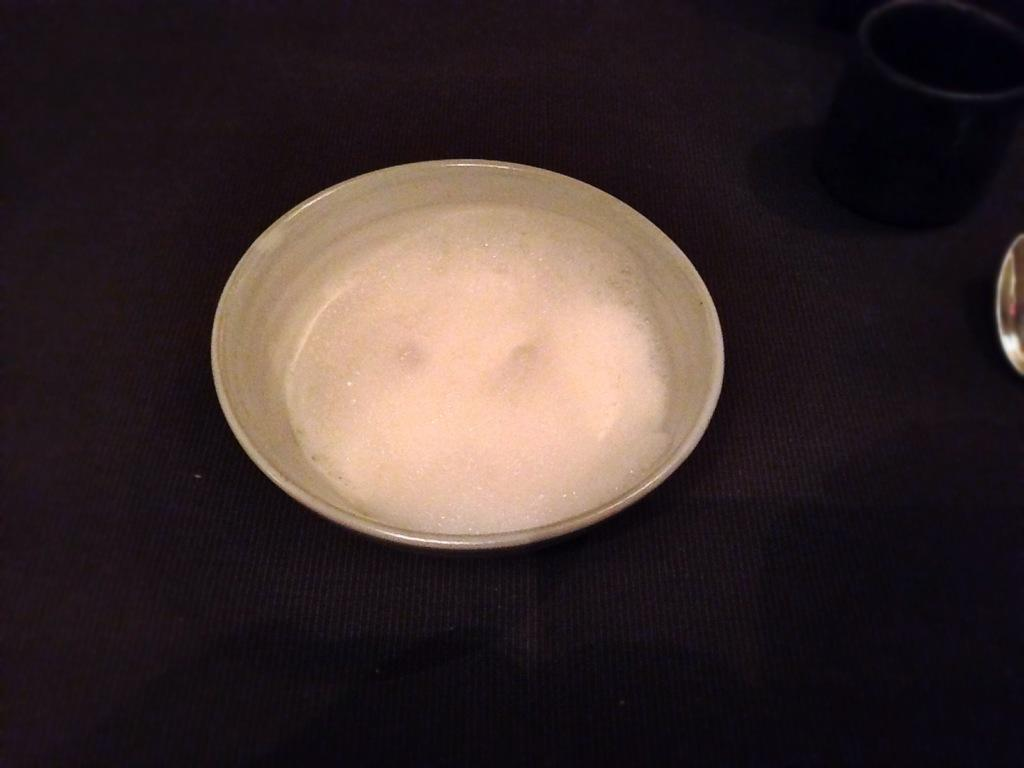What is in the bowl that is visible in the image? There is sugar in a bowl in the image. What else can be seen in the image besides the sugar? There is a cup and a spoon visible in the image. On what surface are the cup, spoon, and sugar bowl placed? There is a table in the image where these items are placed. What type of rings can be seen on the table in the image? There are no rings present on the table in the image. 